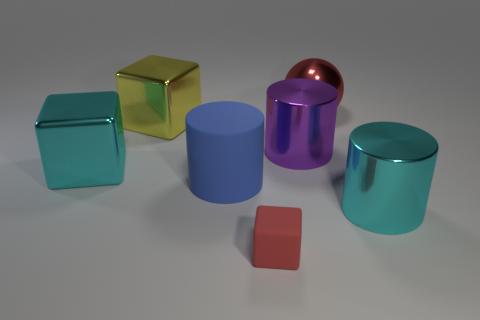Is there any other thing that is the same size as the red rubber block?
Your answer should be very brief. No. There is a rubber thing right of the big blue cylinder; is it the same size as the cyan thing that is on the right side of the purple metallic object?
Make the answer very short. No. What number of large rubber objects are there?
Provide a short and direct response. 1. How many large green spheres have the same material as the cyan cylinder?
Your answer should be very brief. 0. Are there the same number of tiny things that are behind the red sphere and large blue cylinders?
Offer a terse response. No. There is another object that is the same color as the tiny matte thing; what material is it?
Your answer should be compact. Metal. There is a red metal sphere; is it the same size as the cyan thing that is to the left of the red matte object?
Keep it short and to the point. Yes. What number of other things are the same size as the cyan cube?
Provide a succinct answer. 5. What number of other things are the same color as the small cube?
Ensure brevity in your answer.  1. How many other things are the same shape as the big red shiny object?
Keep it short and to the point. 0. 